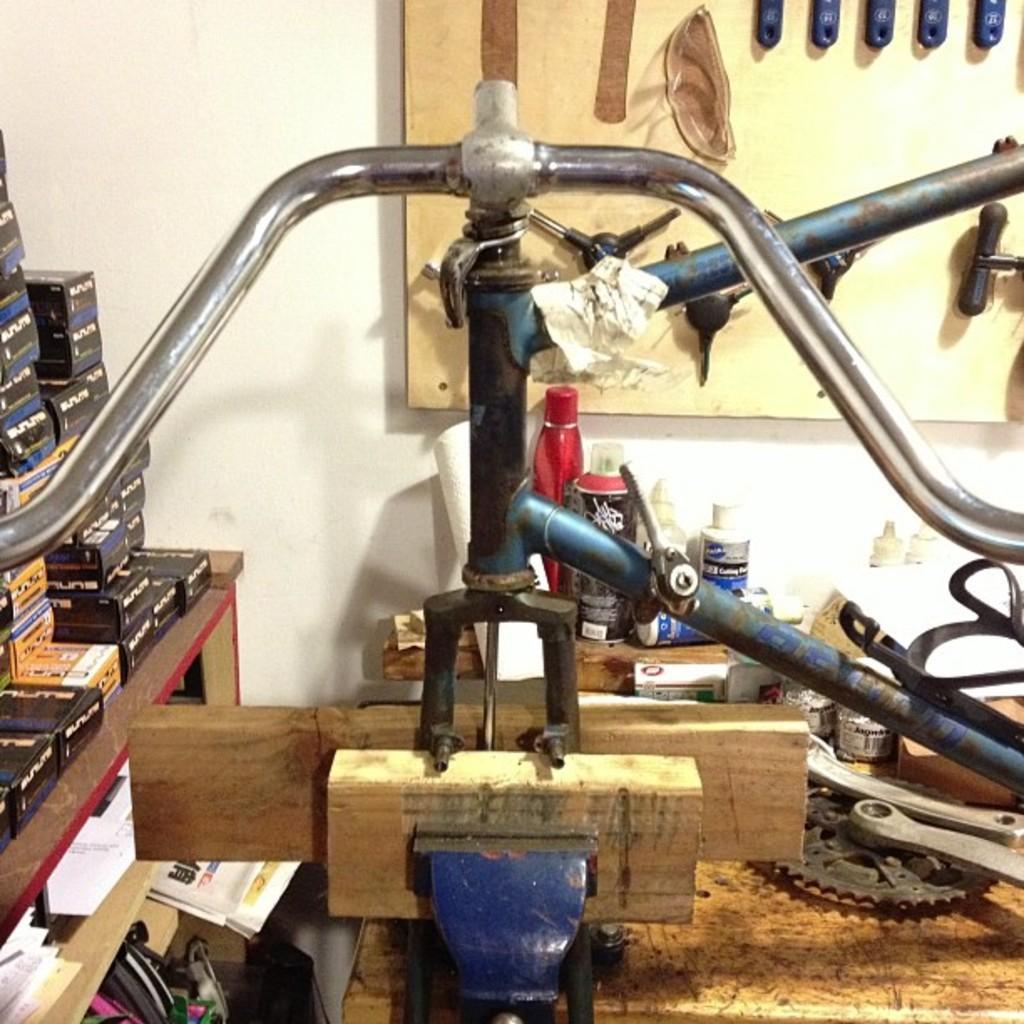How would you summarize this image in a sentence or two? In this image there are metal rods and wooden planks on the table having metal objects. There are bottles on the wooden plank. Left side there is a table having boxes, papers and few objects. Few tools are attached to the board. Background there is a wall having a board attached to it. 